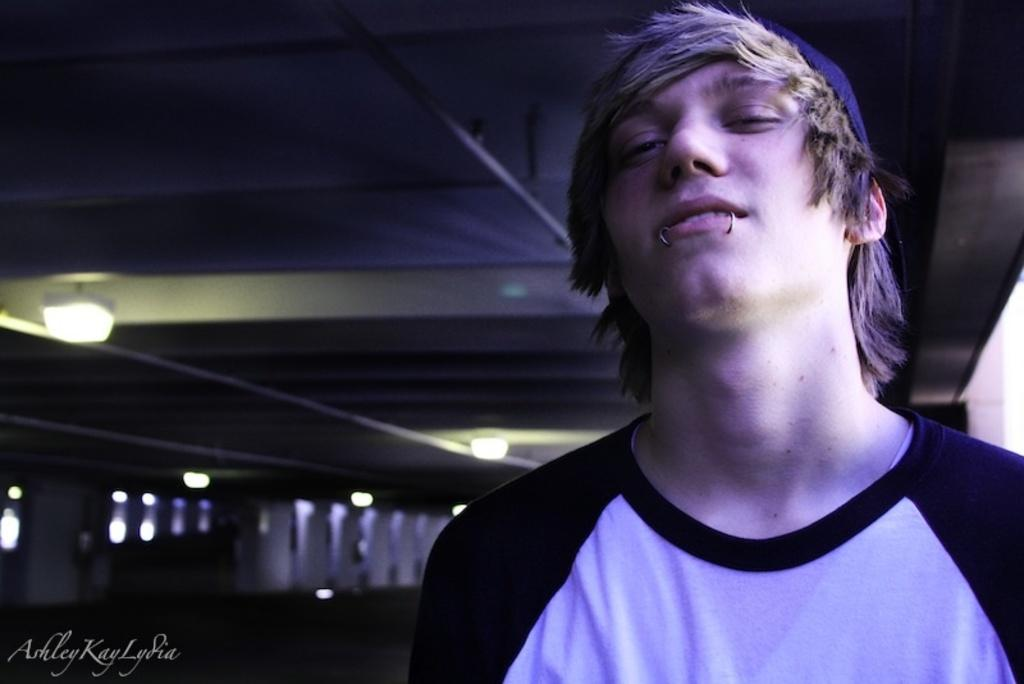Who is present in the image? There is a man in the image. What is the man wearing? The man is wearing a black and white t-shirt. What part of the room can be seen in the image? The ceiling is visible in the image. What can be seen illuminating the room? Lights are present in the image. Where is the text located in the image? The text is in the bottom left corner of the image. What type of fish can be seen swimming in the image? There is no fish present in the image. Can you hear the man whistling in the image? There is no indication of sound in the image, so it cannot be determined if the man is whistling. 